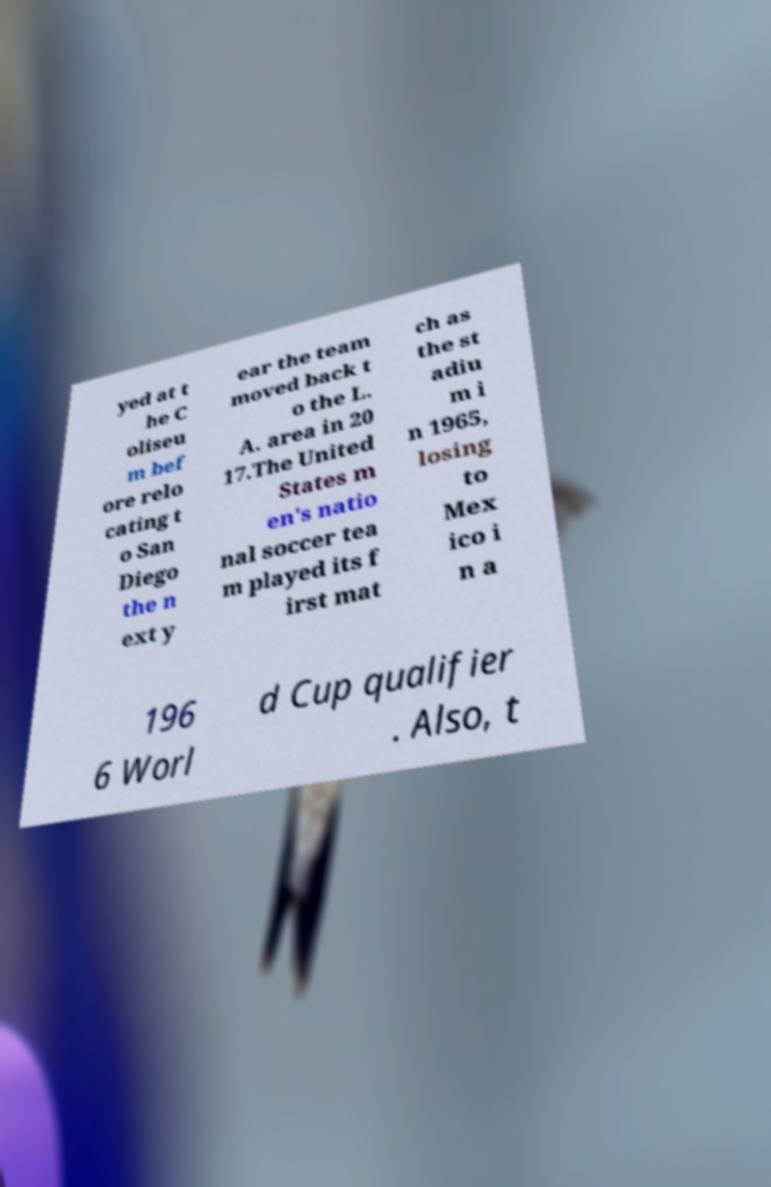Please read and relay the text visible in this image. What does it say? yed at t he C oliseu m bef ore relo cating t o San Diego the n ext y ear the team moved back t o the L. A. area in 20 17.The United States m en's natio nal soccer tea m played its f irst mat ch as the st adiu m i n 1965, losing to Mex ico i n a 196 6 Worl d Cup qualifier . Also, t 